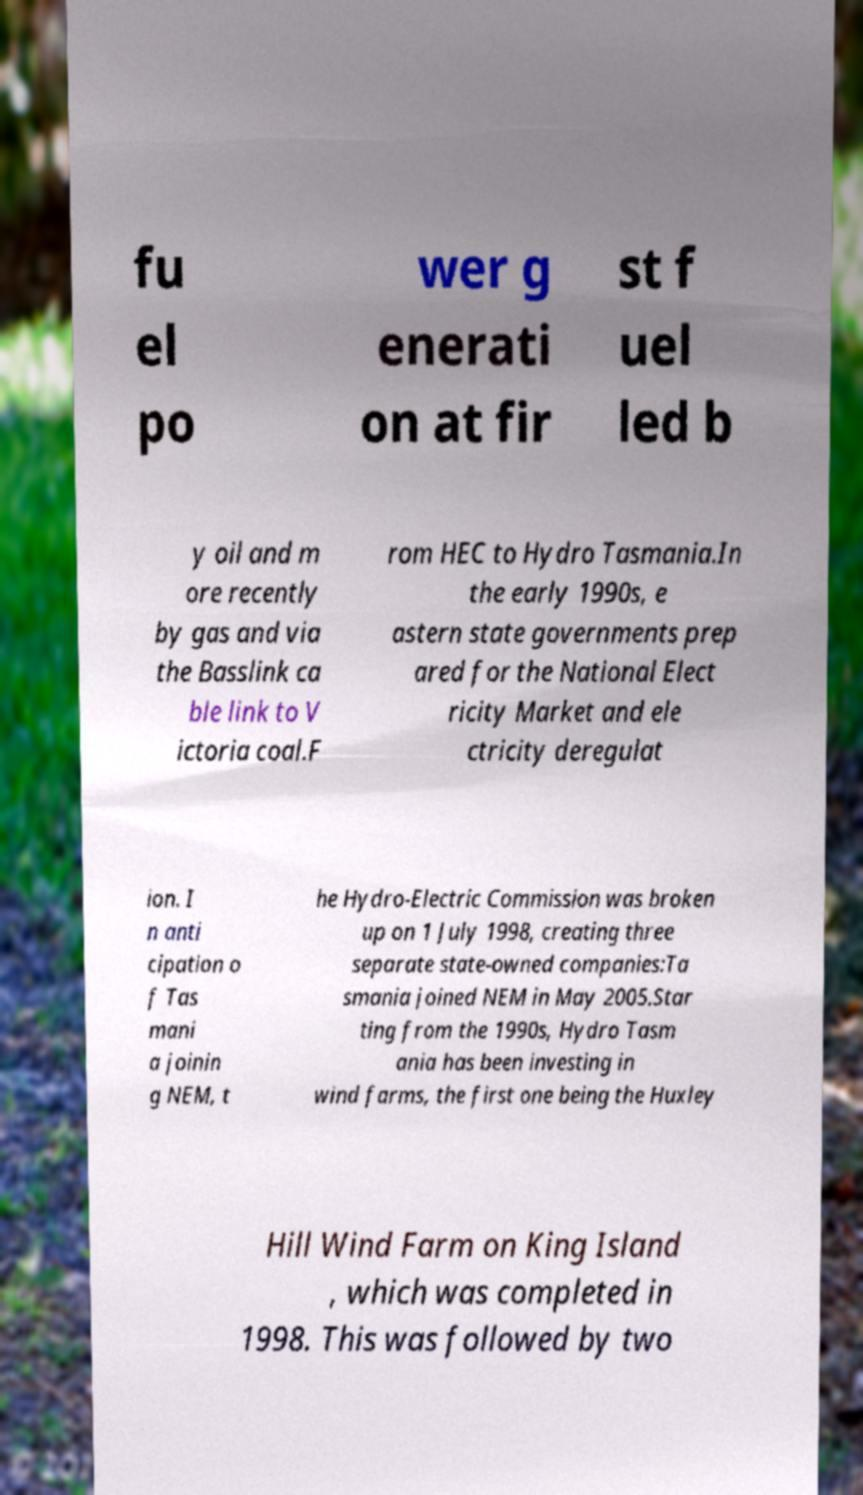Please identify and transcribe the text found in this image. fu el po wer g enerati on at fir st f uel led b y oil and m ore recently by gas and via the Basslink ca ble link to V ictoria coal.F rom HEC to Hydro Tasmania.In the early 1990s, e astern state governments prep ared for the National Elect ricity Market and ele ctricity deregulat ion. I n anti cipation o f Tas mani a joinin g NEM, t he Hydro-Electric Commission was broken up on 1 July 1998, creating three separate state-owned companies:Ta smania joined NEM in May 2005.Star ting from the 1990s, Hydro Tasm ania has been investing in wind farms, the first one being the Huxley Hill Wind Farm on King Island , which was completed in 1998. This was followed by two 